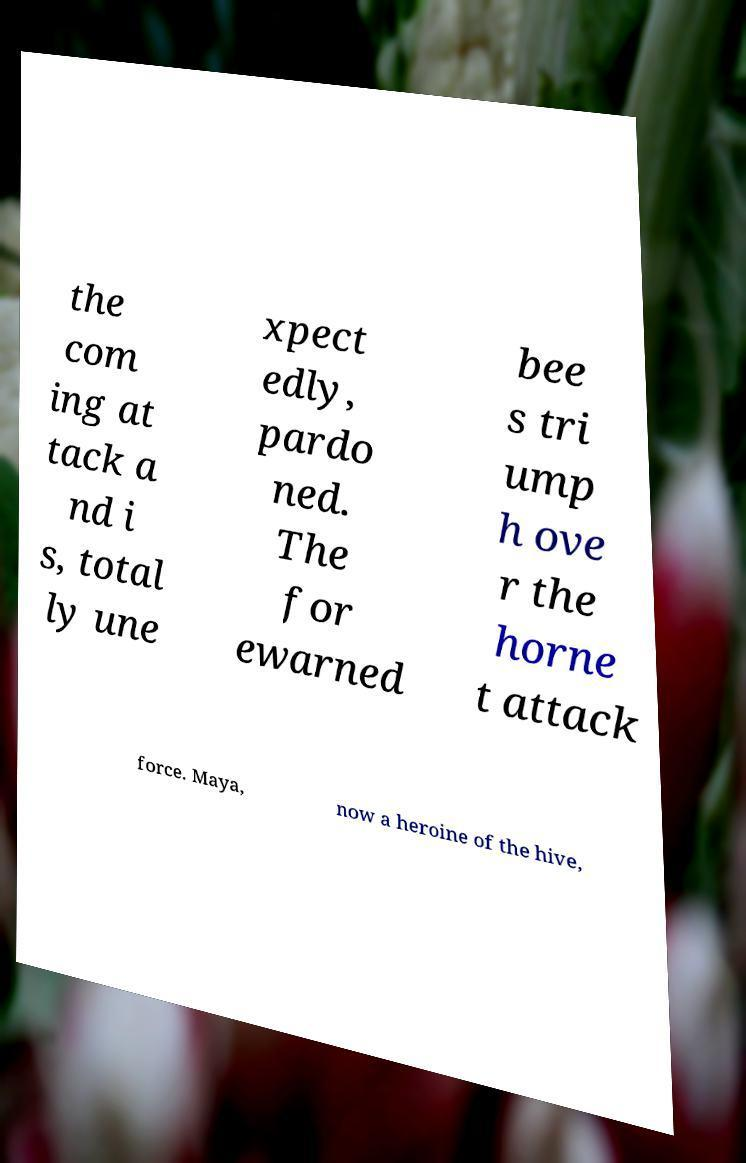I need the written content from this picture converted into text. Can you do that? the com ing at tack a nd i s, total ly une xpect edly, pardo ned. The for ewarned bee s tri ump h ove r the horne t attack force. Maya, now a heroine of the hive, 